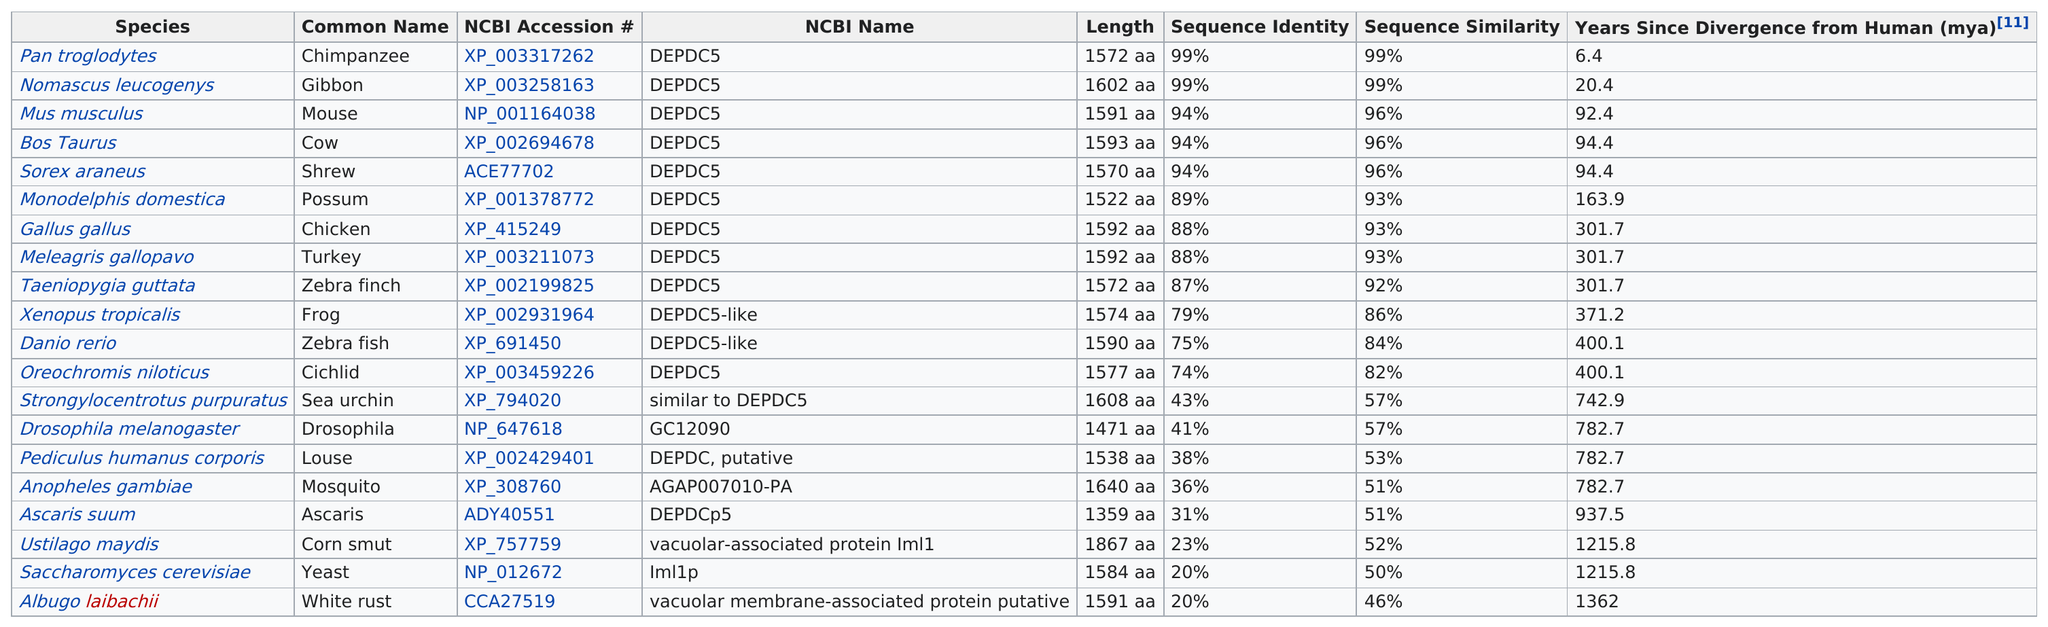Specify some key components in this picture. Since the zebra finch diverged from humans, approximately 301.7 million years have passed. A study has found that the frog and zebra fish have a difference of 4% in their genetic makeup. The lengths of each species listed are 1572 amino acids, 1602 amino acids, 1591 amino acids, 1593 amino acids, 1570 amino acids, 1522 amino acids, 1592 amino acids, 1592 amino acids, 1572 amino acids, 1574 amino acids, 1590 amino acids, 1577 amino acids, 1608 amino acids, 1471 amino acids, 1538 amino acids, 1640 amino acids, 1359 amino acids, 1867 amino acids, 1584 amino acids, and 1591 amino acids. The species Pan troglodytes and Nomascus leucogenys have a high level of sequence identity, at 99%, making them the only species with this level of similarity. The study compared the genetic sequence of several species, including Pan troglodytes, Nomascus leucogenys, Mus musculus, Bos Taurus, Sorex araneus, Monodelphis domestica, Gallus gallus, Meleagris gallopavo, and Taeniopygia guttata, and identified those species that have at least 87% sequence identity. 